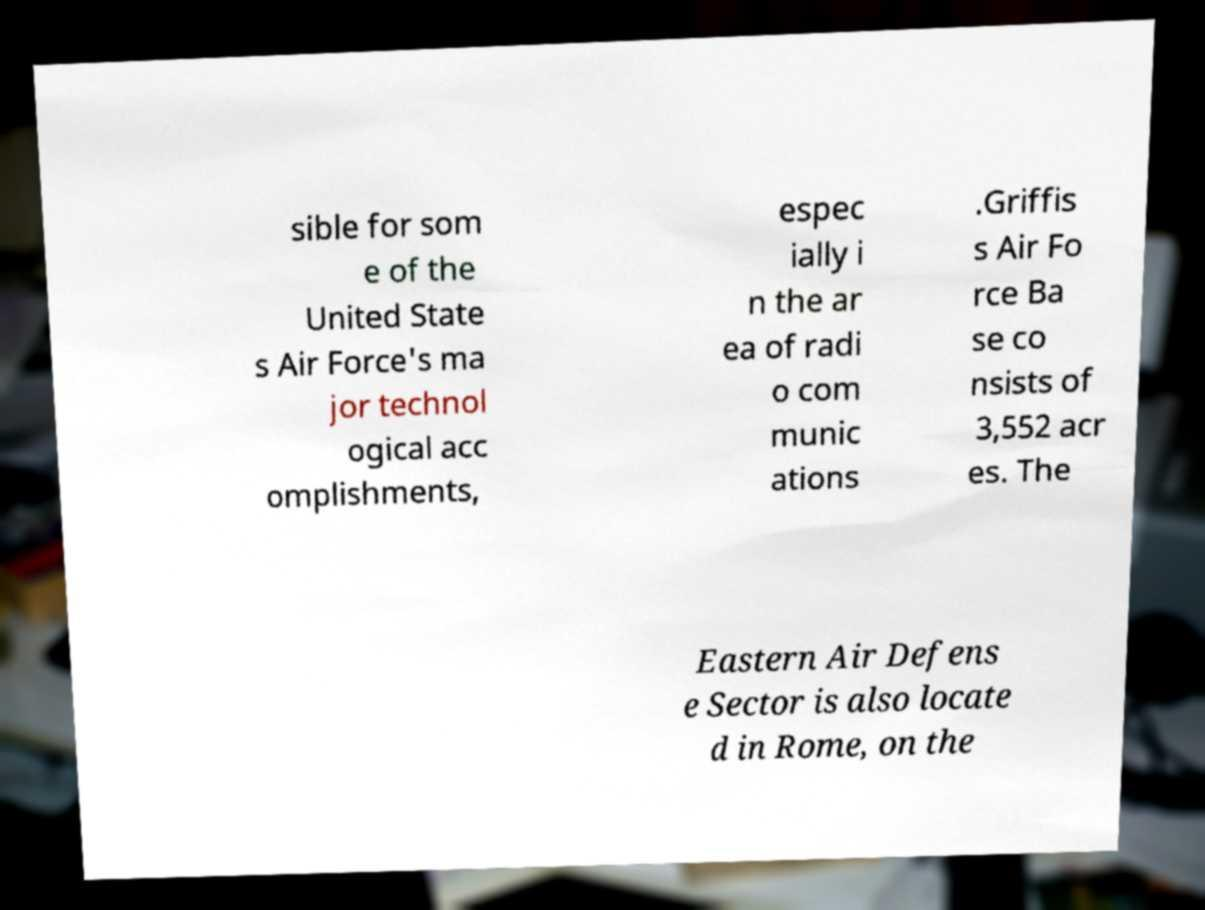Please identify and transcribe the text found in this image. sible for som e of the United State s Air Force's ma jor technol ogical acc omplishments, espec ially i n the ar ea of radi o com munic ations .Griffis s Air Fo rce Ba se co nsists of 3,552 acr es. The Eastern Air Defens e Sector is also locate d in Rome, on the 